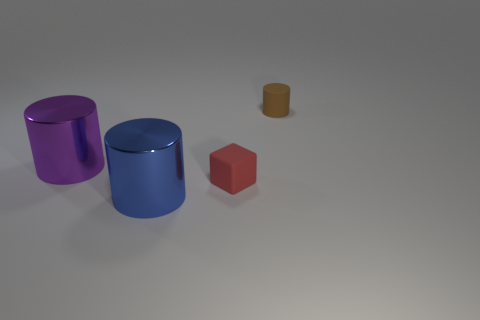Add 2 large metallic things. How many objects exist? 6 Subtract all cylinders. How many objects are left? 1 Subtract all large purple cylinders. Subtract all large gray matte things. How many objects are left? 3 Add 4 big purple metal things. How many big purple metal things are left? 5 Add 2 small objects. How many small objects exist? 4 Subtract 0 green cylinders. How many objects are left? 4 